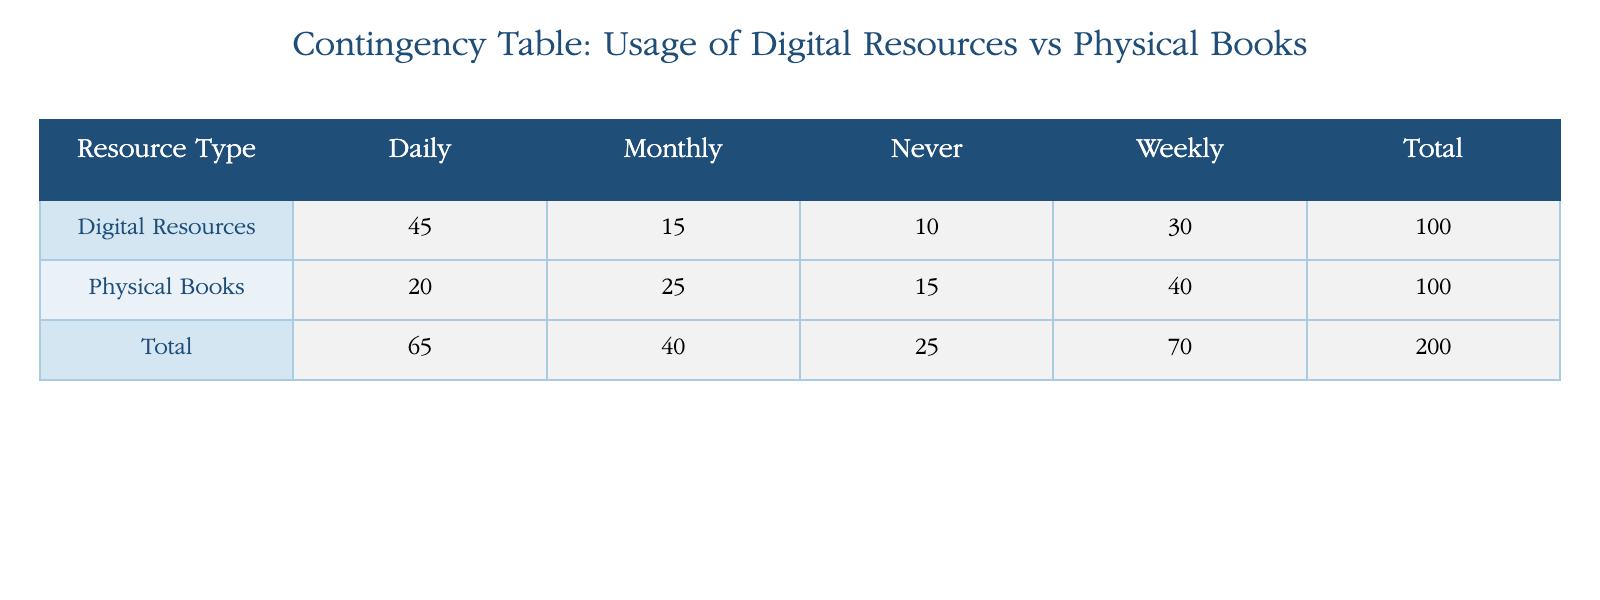What is the total number of students who use digital resources? To find the total number of students who use digital resources, we can add up the counts from all usage frequency categories: 45 (Daily) + 30 (Weekly) + 15 (Monthly) + 10 (Never) = 100.
Answer: 100 How many students use physical books weekly? The table indicates that 40 students use physical books weekly.
Answer: 40 Which resource type has higher daily usage? Comparing the daily usage, 45 students use digital resources daily, while 20 students use physical books daily. Since 45 is greater than 20, digital resources have higher daily usage.
Answer: Digital Resources What is the difference in total student count between digital resources and physical books? The total student count for digital resources is 100, and for physical books, it is 100 as well. The difference is 100 - 100 = 0.
Answer: 0 Are there more students who never use digital resources or physical books? For digital resources, 10 students never use them, whereas 15 students never use physical books. Since 15 is greater than 10, there are more students who never use physical books.
Answer: No What percentage of students use physical books daily compared to those who use digital resources daily? The number of students who use physical books daily is 20, while those using digital resources daily is 45. To find the percentage, we use the formula: (20/45) * 100 = 44.44%.
Answer: 44.44% What is the total number of students who use resources monthly? We need to sum the counts for the monthly usage frequency for both resource types: 15 (Digital Resources) + 25 (Physical Books) = 40.
Answer: 40 If a student uses digital resources weekly, what is the probability of this student using physical books never? From the table, there are 30 students who use digital resources weekly while 15 students never use physical books. To find the probability, we divide the number of students who never use physical books (15) by the total number of students who use digital resources (100): 15/100 = 0.15 or 15%.
Answer: 15% What is the average usage frequency for students using physical books? To find the average usage frequency, we calculate the total student counts for physical books: (20 + 40 + 25 + 15) = 100, and then divide by the number of frequency categories, which is 4. So, 100/4 = 25.
Answer: 25 